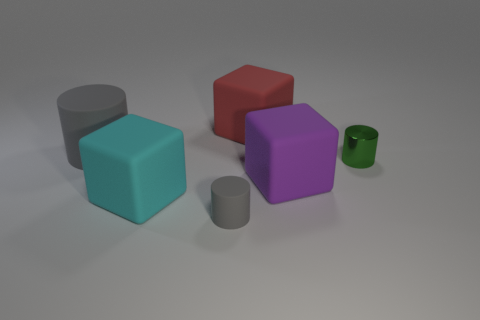Does the matte cylinder behind the purple thing have the same color as the tiny matte object?
Provide a succinct answer. Yes. Are there any other things of the same color as the large rubber cylinder?
Ensure brevity in your answer.  Yes. Is the number of purple matte things that are left of the large cylinder less than the number of tiny green metal objects that are on the right side of the big red block?
Offer a terse response. Yes. What number of other things are made of the same material as the big purple block?
Offer a very short reply. 4. Does the big purple cube have the same material as the green object?
Your response must be concise. No. What number of other objects are there of the same size as the red matte cube?
Give a very brief answer. 3. There is a cylinder right of the big cube that is behind the tiny shiny thing; what size is it?
Offer a very short reply. Small. There is a tiny thing on the right side of the big rubber thing that is behind the gray cylinder that is behind the tiny gray rubber thing; what color is it?
Offer a terse response. Green. How big is the cube that is both in front of the large red rubber cube and behind the large cyan cube?
Offer a terse response. Large. What number of other objects are there of the same shape as the large cyan object?
Your answer should be very brief. 2. 